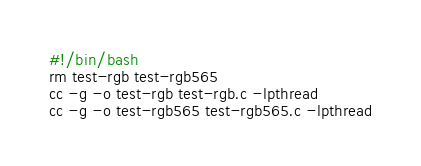Convert code to text. <code><loc_0><loc_0><loc_500><loc_500><_Bash_>#!/bin/bash
rm test-rgb test-rgb565
cc -g -o test-rgb test-rgb.c -lpthread
cc -g -o test-rgb565 test-rgb565.c -lpthread
</code> 